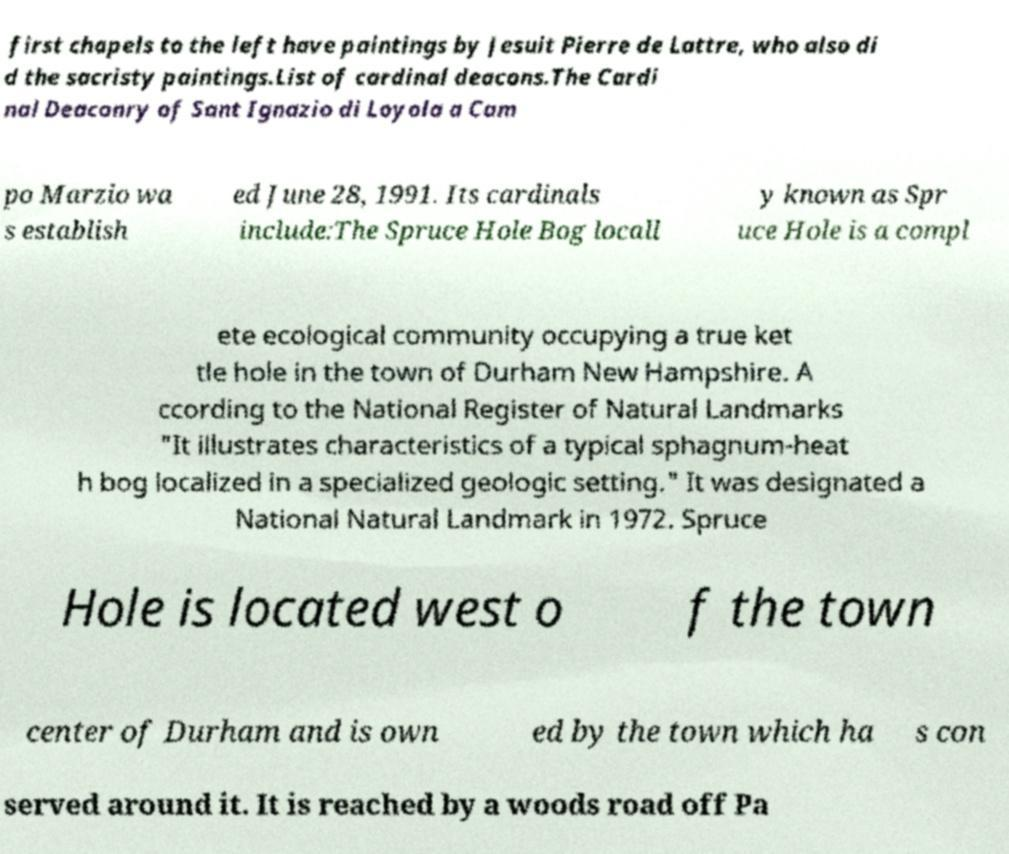For documentation purposes, I need the text within this image transcribed. Could you provide that? first chapels to the left have paintings by Jesuit Pierre de Lattre, who also di d the sacristy paintings.List of cardinal deacons.The Cardi nal Deaconry of Sant Ignazio di Loyola a Cam po Marzio wa s establish ed June 28, 1991. Its cardinals include:The Spruce Hole Bog locall y known as Spr uce Hole is a compl ete ecological community occupying a true ket tle hole in the town of Durham New Hampshire. A ccording to the National Register of Natural Landmarks "It illustrates characteristics of a typical sphagnum-heat h bog localized in a specialized geologic setting." It was designated a National Natural Landmark in 1972. Spruce Hole is located west o f the town center of Durham and is own ed by the town which ha s con served around it. It is reached by a woods road off Pa 